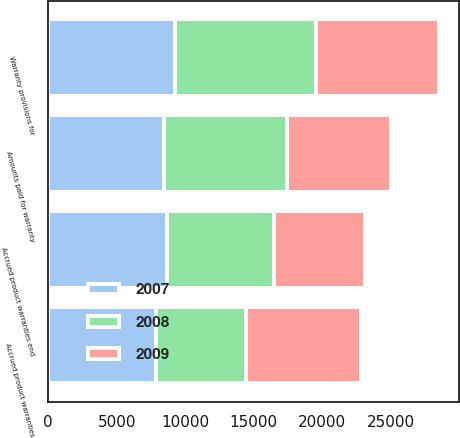Convert chart to OTSL. <chart><loc_0><loc_0><loc_500><loc_500><stacked_bar_chart><ecel><fcel>Accrued product warranties<fcel>Amounts paid for warranty<fcel>Warranty provisions for<fcel>Accrued product warranties end<nl><fcel>2007<fcel>7826<fcel>8426<fcel>9267<fcel>8667<nl><fcel>2008<fcel>6594<fcel>9016<fcel>10248<fcel>7826<nl><fcel>2009<fcel>8426<fcel>7573<fcel>8993<fcel>6594<nl></chart> 